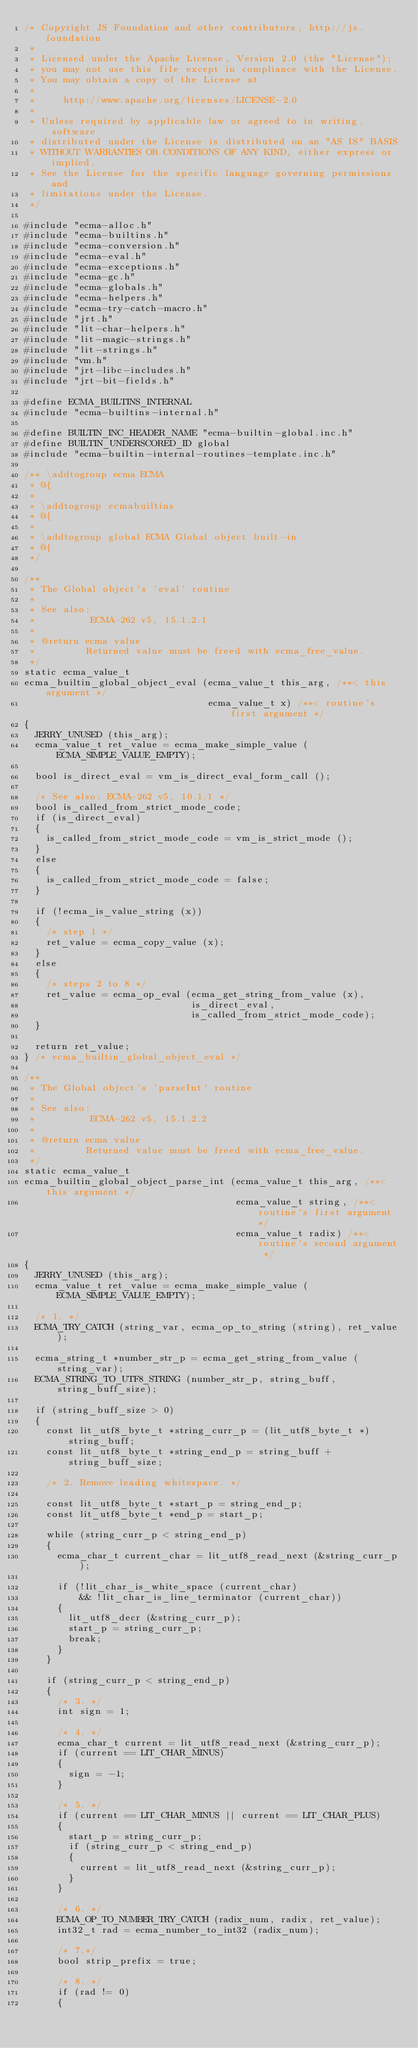Convert code to text. <code><loc_0><loc_0><loc_500><loc_500><_C_>/* Copyright JS Foundation and other contributors, http://js.foundation
 *
 * Licensed under the Apache License, Version 2.0 (the "License");
 * you may not use this file except in compliance with the License.
 * You may obtain a copy of the License at
 *
 *     http://www.apache.org/licenses/LICENSE-2.0
 *
 * Unless required by applicable law or agreed to in writing, software
 * distributed under the License is distributed on an "AS IS" BASIS
 * WITHOUT WARRANTIES OR CONDITIONS OF ANY KIND, either express or implied.
 * See the License for the specific language governing permissions and
 * limitations under the License.
 */

#include "ecma-alloc.h"
#include "ecma-builtins.h"
#include "ecma-conversion.h"
#include "ecma-eval.h"
#include "ecma-exceptions.h"
#include "ecma-gc.h"
#include "ecma-globals.h"
#include "ecma-helpers.h"
#include "ecma-try-catch-macro.h"
#include "jrt.h"
#include "lit-char-helpers.h"
#include "lit-magic-strings.h"
#include "lit-strings.h"
#include "vm.h"
#include "jrt-libc-includes.h"
#include "jrt-bit-fields.h"

#define ECMA_BUILTINS_INTERNAL
#include "ecma-builtins-internal.h"

#define BUILTIN_INC_HEADER_NAME "ecma-builtin-global.inc.h"
#define BUILTIN_UNDERSCORED_ID global
#include "ecma-builtin-internal-routines-template.inc.h"

/** \addtogroup ecma ECMA
 * @{
 *
 * \addtogroup ecmabuiltins
 * @{
 *
 * \addtogroup global ECMA Global object built-in
 * @{
 */

/**
 * The Global object's 'eval' routine
 *
 * See also:
 *          ECMA-262 v5, 15.1.2.1
 *
 * @return ecma value
 *         Returned value must be freed with ecma_free_value.
 */
static ecma_value_t
ecma_builtin_global_object_eval (ecma_value_t this_arg, /**< this argument */
                                 ecma_value_t x) /**< routine's first argument */
{
  JERRY_UNUSED (this_arg);
  ecma_value_t ret_value = ecma_make_simple_value (ECMA_SIMPLE_VALUE_EMPTY);

  bool is_direct_eval = vm_is_direct_eval_form_call ();

  /* See also: ECMA-262 v5, 10.1.1 */
  bool is_called_from_strict_mode_code;
  if (is_direct_eval)
  {
    is_called_from_strict_mode_code = vm_is_strict_mode ();
  }
  else
  {
    is_called_from_strict_mode_code = false;
  }

  if (!ecma_is_value_string (x))
  {
    /* step 1 */
    ret_value = ecma_copy_value (x);
  }
  else
  {
    /* steps 2 to 8 */
    ret_value = ecma_op_eval (ecma_get_string_from_value (x),
                              is_direct_eval,
                              is_called_from_strict_mode_code);
  }

  return ret_value;
} /* ecma_builtin_global_object_eval */

/**
 * The Global object's 'parseInt' routine
 *
 * See also:
 *          ECMA-262 v5, 15.1.2.2
 *
 * @return ecma value
 *         Returned value must be freed with ecma_free_value.
 */
static ecma_value_t
ecma_builtin_global_object_parse_int (ecma_value_t this_arg, /**< this argument */
                                      ecma_value_t string, /**< routine's first argument */
                                      ecma_value_t radix) /**< routine's second argument */
{
  JERRY_UNUSED (this_arg);
  ecma_value_t ret_value = ecma_make_simple_value (ECMA_SIMPLE_VALUE_EMPTY);

  /* 1. */
  ECMA_TRY_CATCH (string_var, ecma_op_to_string (string), ret_value);

  ecma_string_t *number_str_p = ecma_get_string_from_value (string_var);
  ECMA_STRING_TO_UTF8_STRING (number_str_p, string_buff, string_buff_size);

  if (string_buff_size > 0)
  {
    const lit_utf8_byte_t *string_curr_p = (lit_utf8_byte_t *) string_buff;
    const lit_utf8_byte_t *string_end_p = string_buff + string_buff_size;

    /* 2. Remove leading whitespace. */

    const lit_utf8_byte_t *start_p = string_end_p;
    const lit_utf8_byte_t *end_p = start_p;

    while (string_curr_p < string_end_p)
    {
      ecma_char_t current_char = lit_utf8_read_next (&string_curr_p);

      if (!lit_char_is_white_space (current_char)
          && !lit_char_is_line_terminator (current_char))
      {
        lit_utf8_decr (&string_curr_p);
        start_p = string_curr_p;
        break;
      }
    }

    if (string_curr_p < string_end_p)
    {
      /* 3. */
      int sign = 1;

      /* 4. */
      ecma_char_t current = lit_utf8_read_next (&string_curr_p);
      if (current == LIT_CHAR_MINUS)
      {
        sign = -1;
      }

      /* 5. */
      if (current == LIT_CHAR_MINUS || current == LIT_CHAR_PLUS)
      {
        start_p = string_curr_p;
        if (string_curr_p < string_end_p)
        {
          current = lit_utf8_read_next (&string_curr_p);
        }
      }

      /* 6. */
      ECMA_OP_TO_NUMBER_TRY_CATCH (radix_num, radix, ret_value);
      int32_t rad = ecma_number_to_int32 (radix_num);

      /* 7.*/
      bool strip_prefix = true;

      /* 8. */
      if (rad != 0)
      {</code> 